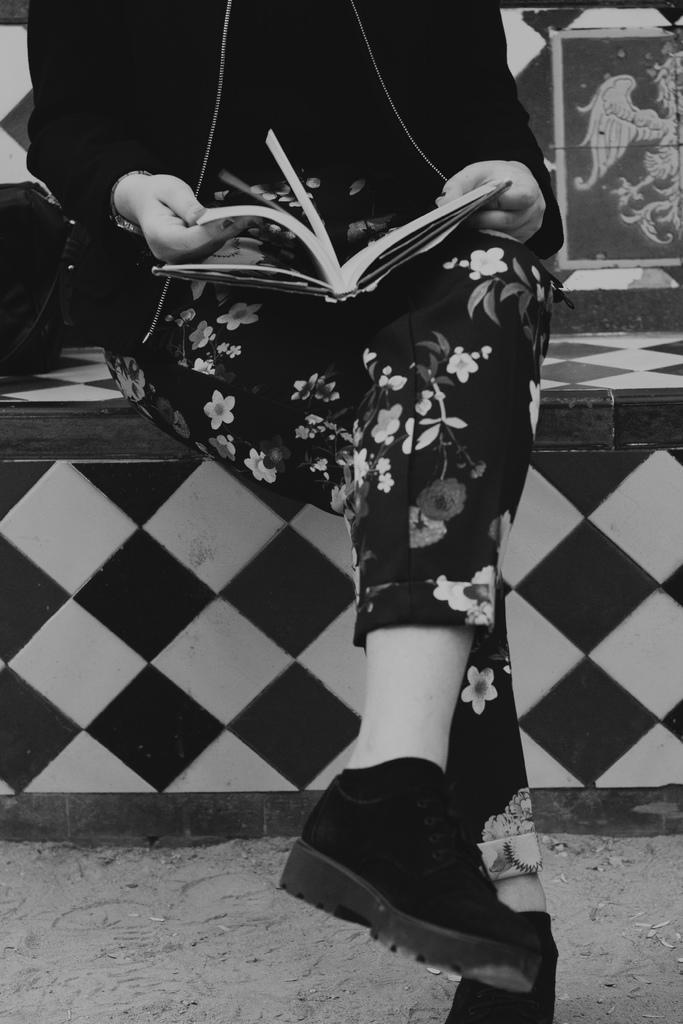Could you give a brief overview of what you see in this image? In this picture there is a woman wearing black color flower track and holding a book in the hand and sitting on the black and white bench. 